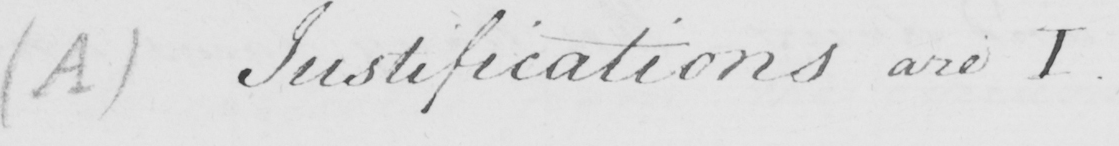Please transcribe the handwritten text in this image. ( A )  Justifications are I 